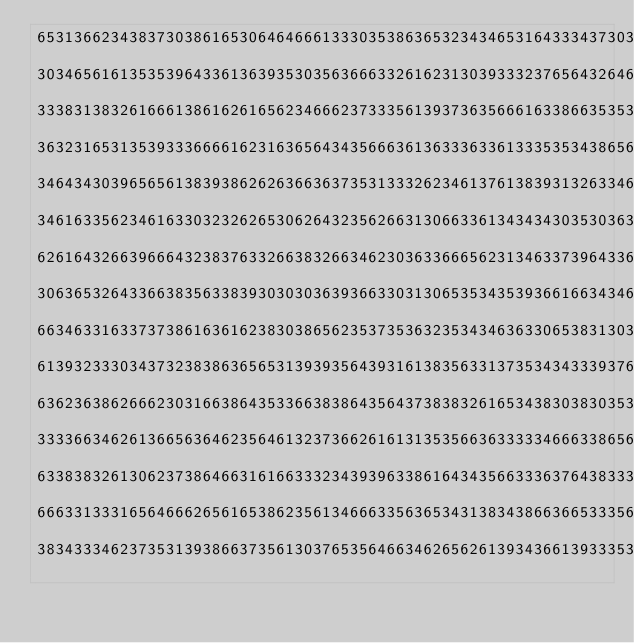Convert code to text. <code><loc_0><loc_0><loc_500><loc_500><_YAML_>65313662343837303861653064646661333035386365323434653164333437303361633737633439
30346561613535396433613639353035636663326162313039333237656432646339643564306363
33383138326166613861626165623466623733356139373635666163386635353136613232386237
36323165313539333666616231636564343566636136333633613335353438656437303338636237
34643430396565613839386262636636373531333262346137613839313263346139613735343630
34616335623461633032326265306264323562663130663361343434303530363439396436643433
62616432663966643238376332663832663462303633666562313463373964336536343762323037
30636532643366383563383930303036393663303130653534353936616634346235396463386464
66346331633737386163616238303865623537353632353434636330653831303764616562613130
61393233303437323838636565313939356439316138356331373534343339376533323731363738
63623638626662303166386435336638386435643738383261653438303830353664663532623430
33336634626136656364623564613237366261613135356636333334666338656566386236386538
63383832613062373864663161663332343939633861643435663336376438333235303737396538
66633133316564666265616538623561346663356365343138343866366533356332666137316462
38343334623735313938663735613037653564663462656261393436613933353263353465303533</code> 